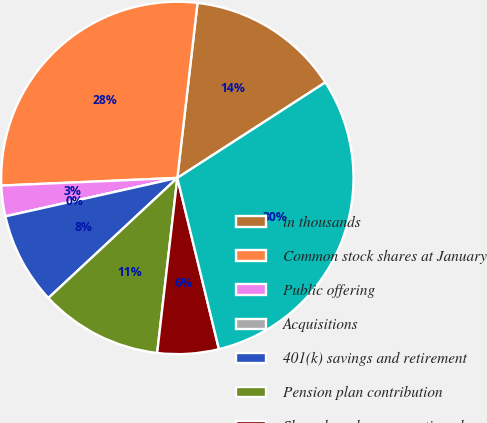<chart> <loc_0><loc_0><loc_500><loc_500><pie_chart><fcel>in thousands<fcel>Common stock shares at January<fcel>Public offering<fcel>Acquisitions<fcel>401(k) savings and retirement<fcel>Pension plan contribution<fcel>Share-based compensation plans<fcel>Common stock shares at<nl><fcel>14.05%<fcel>27.52%<fcel>2.81%<fcel>0.0%<fcel>8.43%<fcel>11.24%<fcel>5.62%<fcel>30.33%<nl></chart> 